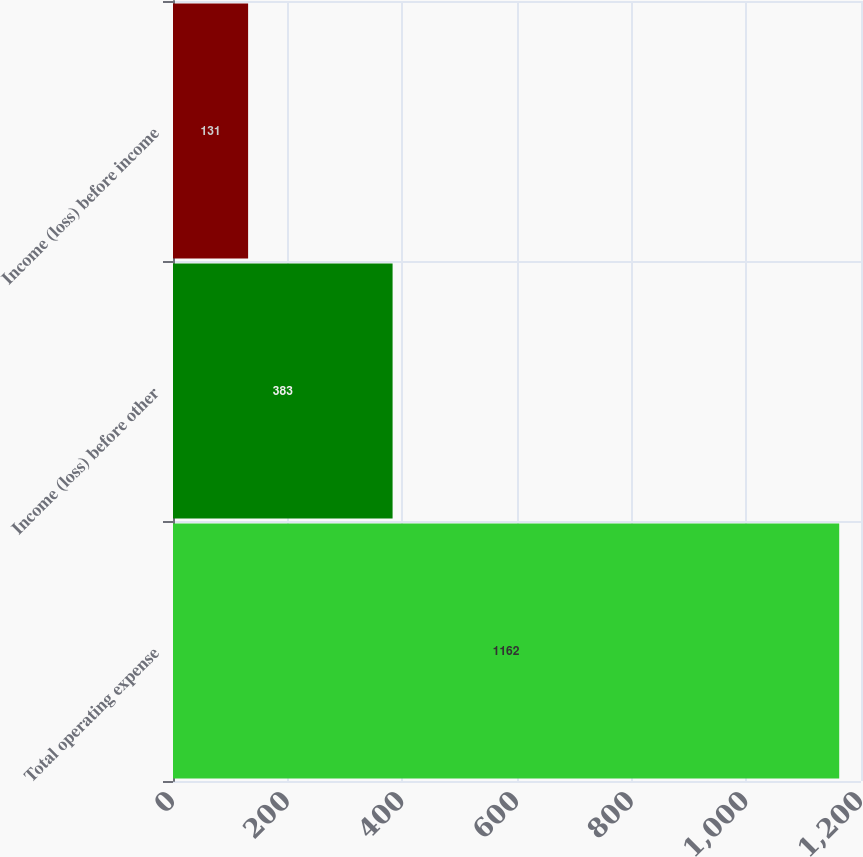<chart> <loc_0><loc_0><loc_500><loc_500><bar_chart><fcel>Total operating expense<fcel>Income (loss) before other<fcel>Income (loss) before income<nl><fcel>1162<fcel>383<fcel>131<nl></chart> 